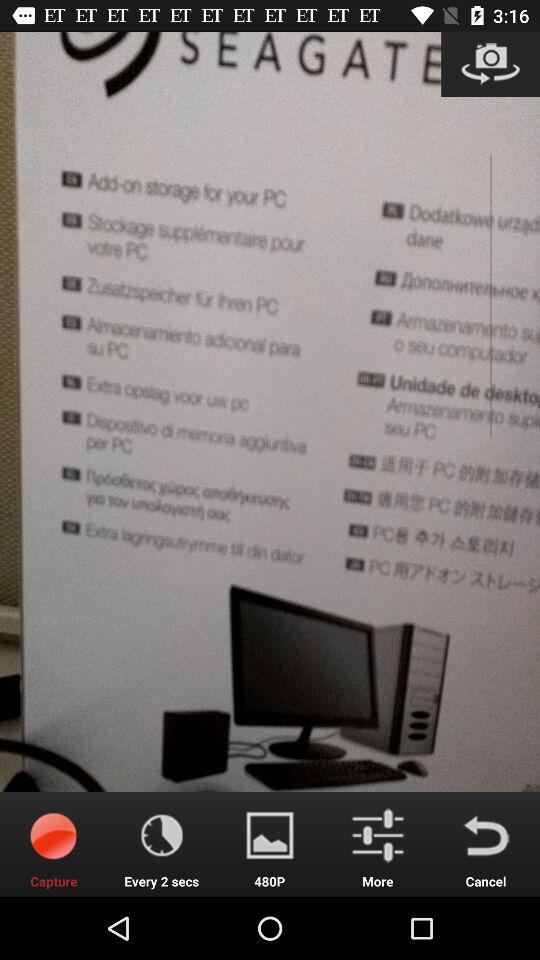What is the displayed resolution? The displayed resolution is 480p. 